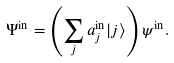<formula> <loc_0><loc_0><loc_500><loc_500>\Psi ^ { \text {in} } = \left ( \sum _ { j } a _ { j } ^ { \text {in} } | j \rangle \right ) \psi ^ { \text {in} } .</formula> 